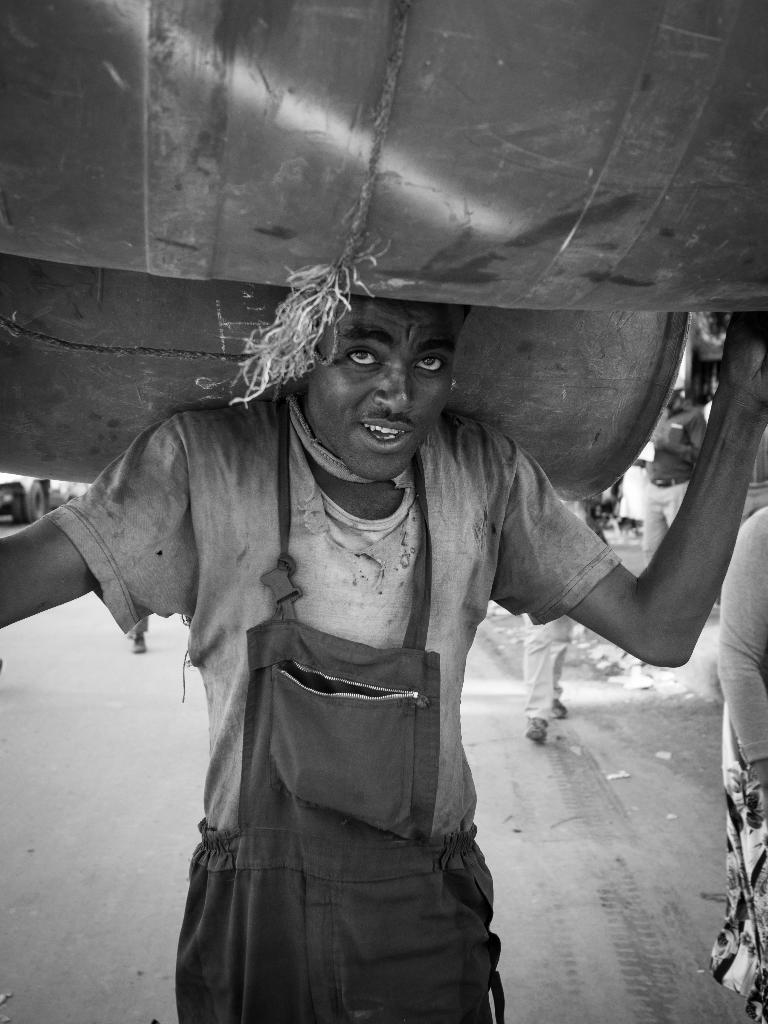What is the color scheme of the image? The image is black and white. What is the person in the image doing? The person is carrying objects on their head in the image. What can be seen at the bottom of the image? There is a road at the bottom of the image. How many girls are present in the image? There is no mention of girls in the image, as it only features a person carrying objects on their head. What type of health-related information can be found in the image? There is no health-related information present in the image, as it is a black and white image of a person carrying objects on their head with a road in the background. 